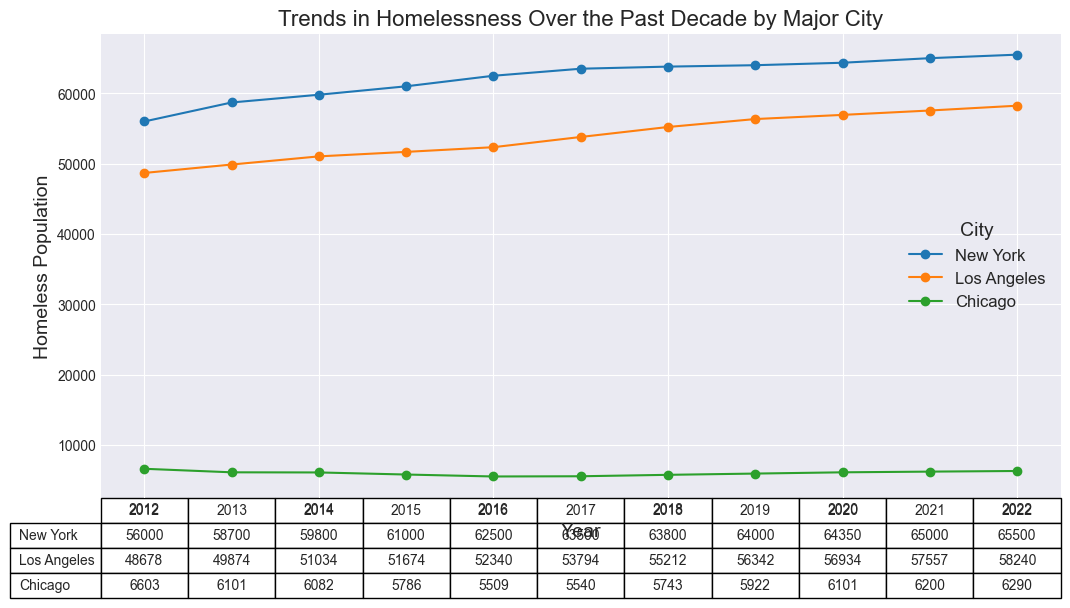What are the trends in homelessness in New York over the past decade? From the graph, observe the line corresponding to New York, which consistently increases each year from 56,000 in 2012 to 65,500 in 2022.
Answer: Consistently increasing Which city experienced the largest increase in homelessness between 2012 and 2022? Calculate the difference for each city: 
- New York: 65,500 - 56,000 = 9,500
- Los Angeles: 58,240 - 48,678 = 9,562
- Chicago: 6,290 - 6,603 = -313 
Los Angeles has the largest increase.
Answer: Los Angeles How does the homelessness trend in Chicago compare to that in Los Angeles between 2012 and 2022? Observe the graph and table for both cities:
- Chicago shows a slight decrease from 6,603 to 6,290.
- Los Angeles shows an increase from 48,678 to 58,240. 
Chicago's trend is decreasing, while Los Angeles's trend is increasing.
Answer: Chicago decreases, Los Angeles increases What is the average homeless population in New York over the decade? Sum the homeless populations in New York for each year and divide by the number of years: (56,000 + 58,700 + 59,800 + 61,000 + 62,500 + 63,500 + 63,800 + 64,000 + 64,350 + 65,000 + 65,500) / 11 = 62,759.09
Answer: 62,759 In what year did Los Angeles surpass 50,000 homeless individuals? From the table and graph, Los Angeles surpasses 50,000 in 2015 with a population of 51,674.
Answer: 2015 How many more homeless individuals were there in New York than in Chicago in 2022? Subtract the homeless population in Chicago from that in New York in 2022: 65,500 - 6,290 = 59,210.
Answer: 59,210 What is the trend in homelessness for all cities combined over the past decade? Add the homeless populations for all cities each year and observe the trend:
- 2012: 56,000 + 48,678 + 6,603 = 111,281
- 2022: 65,500 + 58,240 + 6,290 = 130,030
The trend shows an increase over the decade.
Answer: Increasing Looking at the visual attributes, which city had the smoothest trend line? By examining the plotted lines, New York’s trend line appears to be the most consistently upward without sharp fluctuations.
Answer: New York 